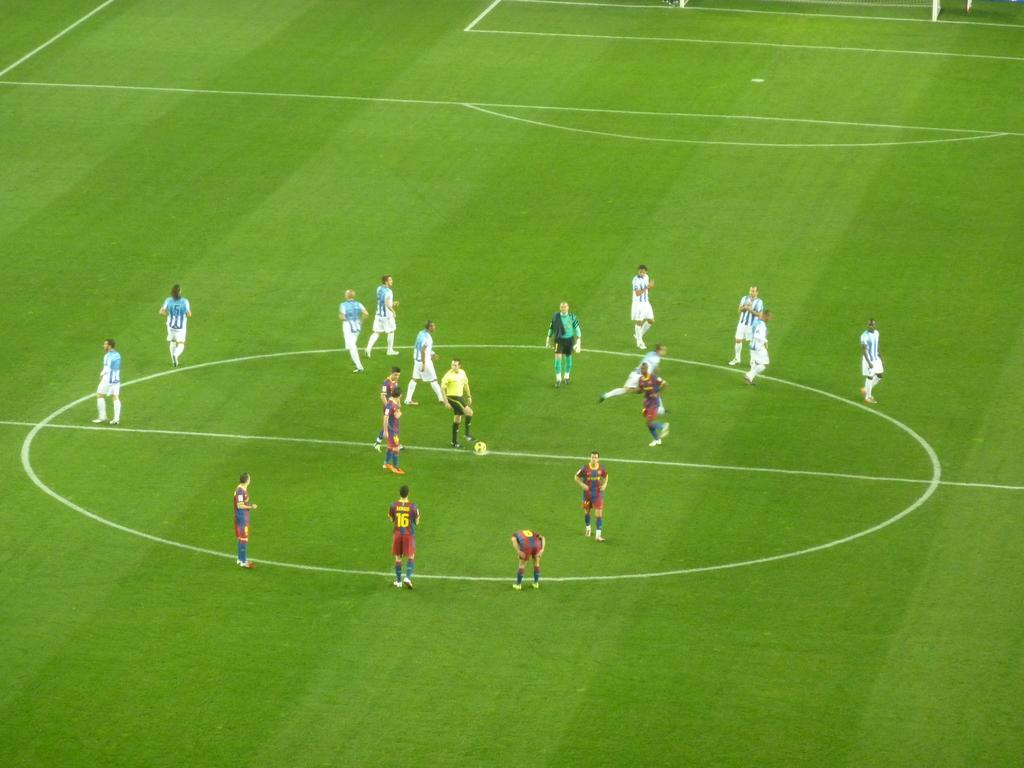Where was the image taken? The image was taken in a playground. What can be seen in the image besides the playground? There are people in the image. What object is visible in the image that might be used for playing? A ball is visible in the image. What theory is being discussed by the people in the image? There is no indication in the image that the people are discussing any theories. 